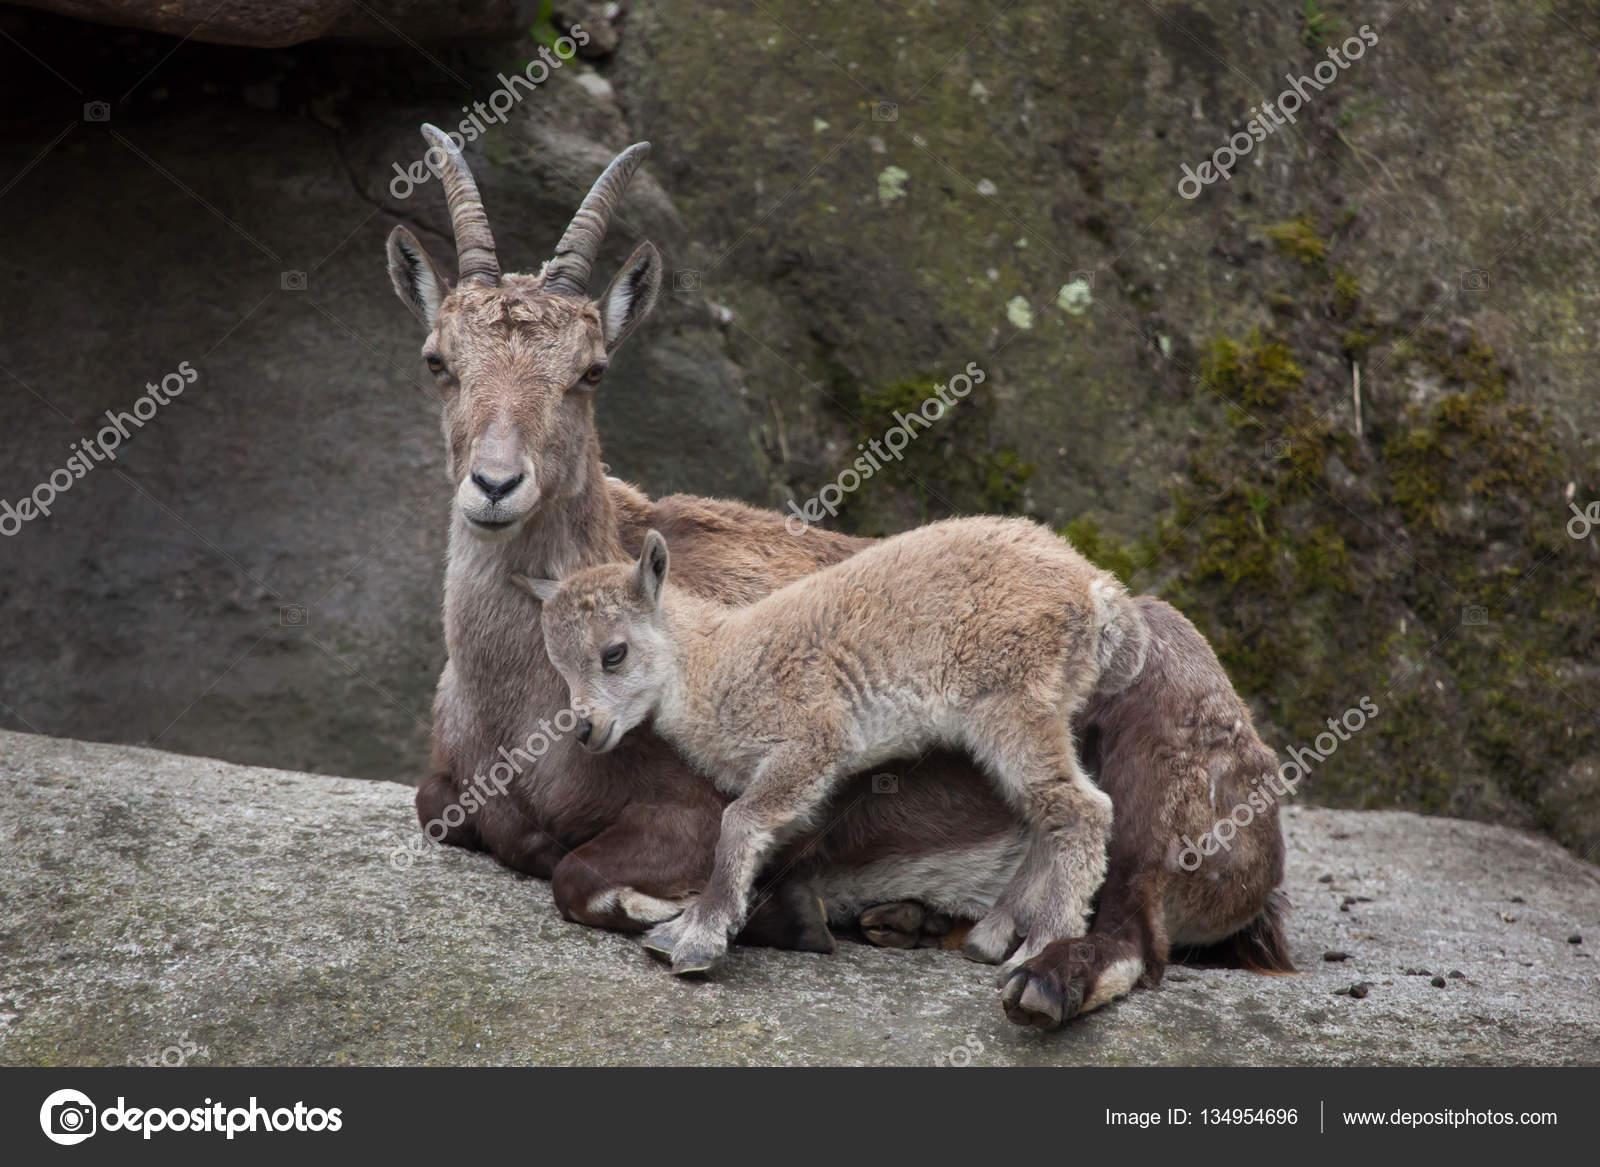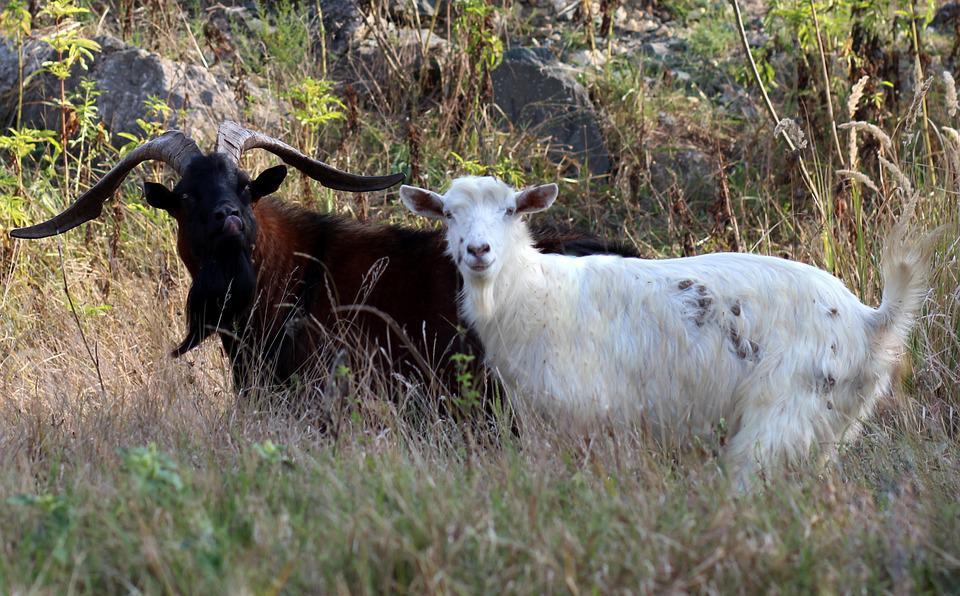The first image is the image on the left, the second image is the image on the right. For the images displayed, is the sentence "There are exactly two mountain goats." factually correct? Answer yes or no. No. The first image is the image on the left, the second image is the image on the right. For the images shown, is this caption "There are only two goats visible." true? Answer yes or no. No. 